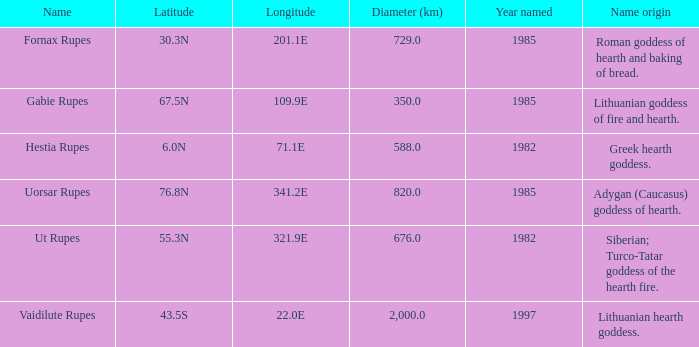At a latitude of 7 Greek hearth goddess. 